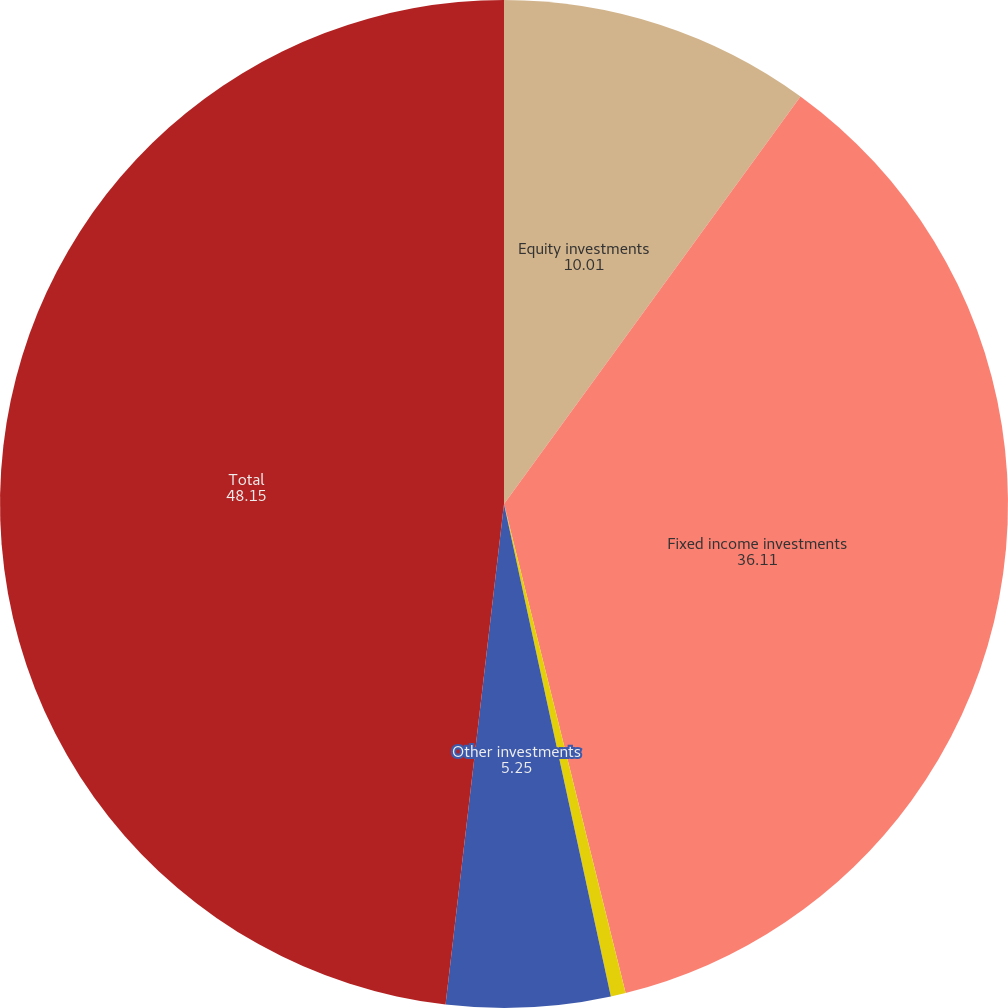Convert chart. <chart><loc_0><loc_0><loc_500><loc_500><pie_chart><fcel>Equity investments<fcel>Fixed income investments<fcel>Short-term investments<fcel>Other investments<fcel>Total<nl><fcel>10.01%<fcel>36.11%<fcel>0.48%<fcel>5.25%<fcel>48.15%<nl></chart> 